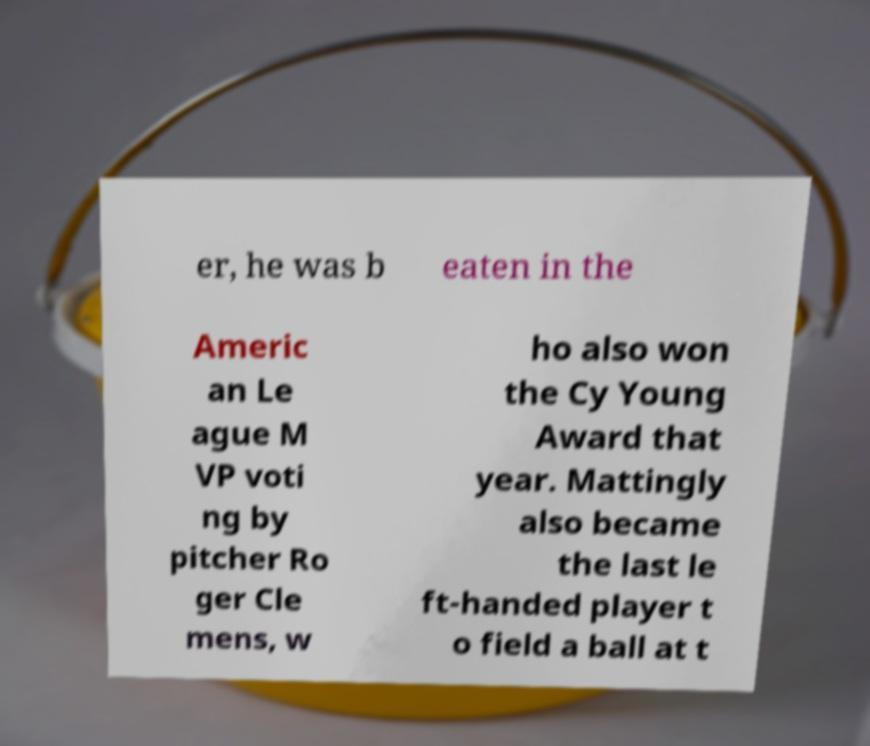For documentation purposes, I need the text within this image transcribed. Could you provide that? er, he was b eaten in the Americ an Le ague M VP voti ng by pitcher Ro ger Cle mens, w ho also won the Cy Young Award that year. Mattingly also became the last le ft-handed player t o field a ball at t 